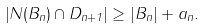<formula> <loc_0><loc_0><loc_500><loc_500>\left | N ( B _ { n } ) \cap D _ { n + 1 } \right | \geq \left | B _ { n } \right | + a _ { n } .</formula> 